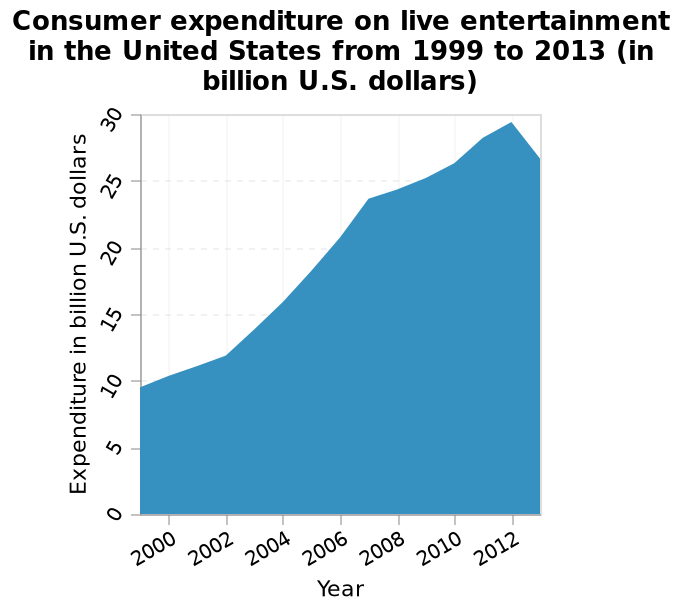<image>
What is the time range covered by the area graph? The area graph covers the years from 1999 to 2013. Offer a thorough analysis of the image. US consumer expenditure on live entertainment decreased after 2012. During 2000-2010 consumer expenditure increased on live entertainment in the US. 